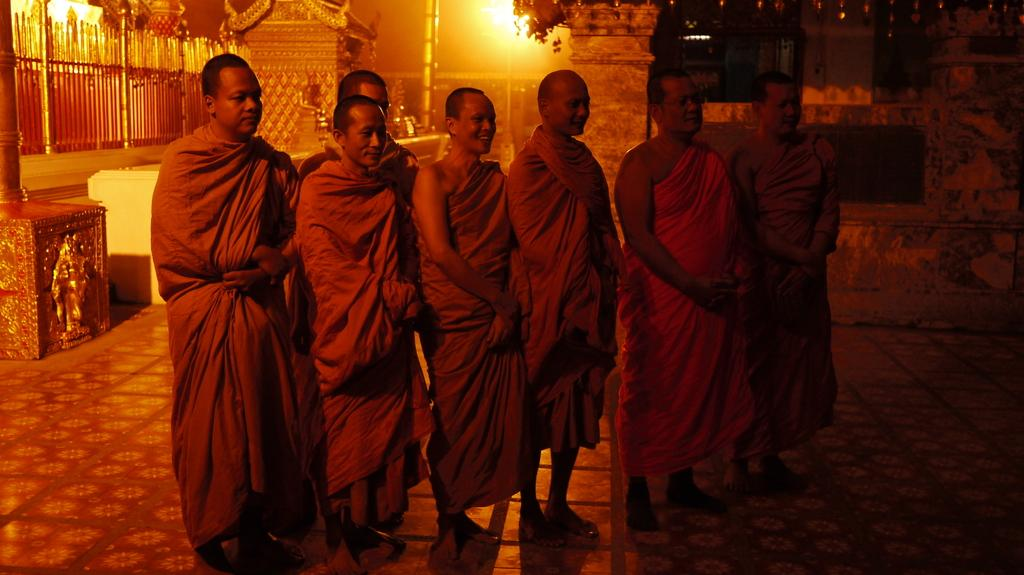How many people are in the image? There is a group of people in the image, but the exact number is not specified. What are the people doing in the image? The people are on the ground, but their specific activity is not mentioned. What can be seen in the background of the image? There is a fence, poles, and some objects in the background of the image. What type of music is being played by the goat in the image? There is no goat or music present in the image. What town is visible in the background of the image? The image does not show a town or any indication of a specific location. 